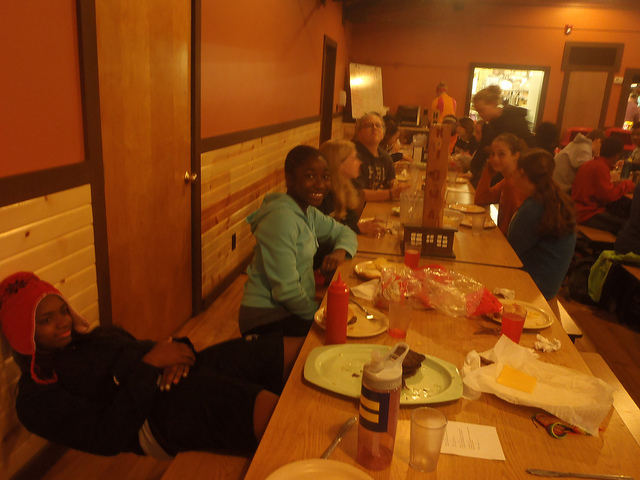<image>Where is the equal sign? It is ambiguous where the equal sign is. It's possible that it could be on a water bottle. What food is on the table? I am not sure what food is on the table. It could be various items like cake, bread, a hamburger, or pizza. Where is the equal sign? I don't know where the equal sign is. It is not visible in the image. What food is on the table? I don't know what food is on the table. It can be cake, bread, hamburger, pizza or burgers. 